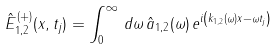<formula> <loc_0><loc_0><loc_500><loc_500>\hat { E } ^ { ( + ) } _ { 1 , 2 } ( x , t _ { j } ) = \int ^ { \infty } _ { 0 } \, d \omega \, \hat { a } _ { 1 , 2 } ( \omega ) \, e ^ { i \left ( k _ { 1 , 2 } ( \omega ) x - \omega t _ { j } \right ) }</formula> 